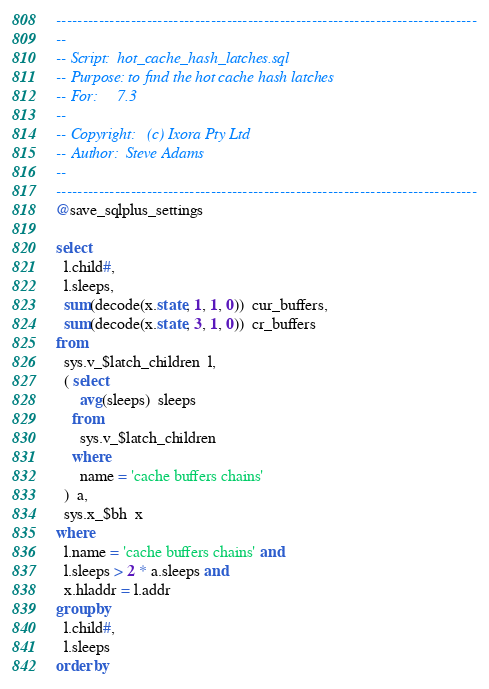Convert code to text. <code><loc_0><loc_0><loc_500><loc_500><_SQL_>-------------------------------------------------------------------------------
--
-- Script:	hot_cache_hash_latches.sql
-- Purpose:	to find the hot cache hash latches
-- For:		7.3
--
-- Copyright:	(c) Ixora Pty Ltd
-- Author:	Steve Adams
--
-------------------------------------------------------------------------------
@save_sqlplus_settings

select
  l.child#,
  l.sleeps,
  sum(decode(x.state, 1, 1, 0))  cur_buffers,
  sum(decode(x.state, 3, 1, 0))  cr_buffers
from
  sys.v_$latch_children  l,
  ( select
      avg(sleeps)  sleeps
    from
      sys.v_$latch_children
    where
      name = 'cache buffers chains'
  )  a,
  sys.x_$bh  x
where
  l.name = 'cache buffers chains' and
  l.sleeps > 2 * a.sleeps and
  x.hladdr = l.addr
group by
  l.child#,
  l.sleeps
order by</code> 